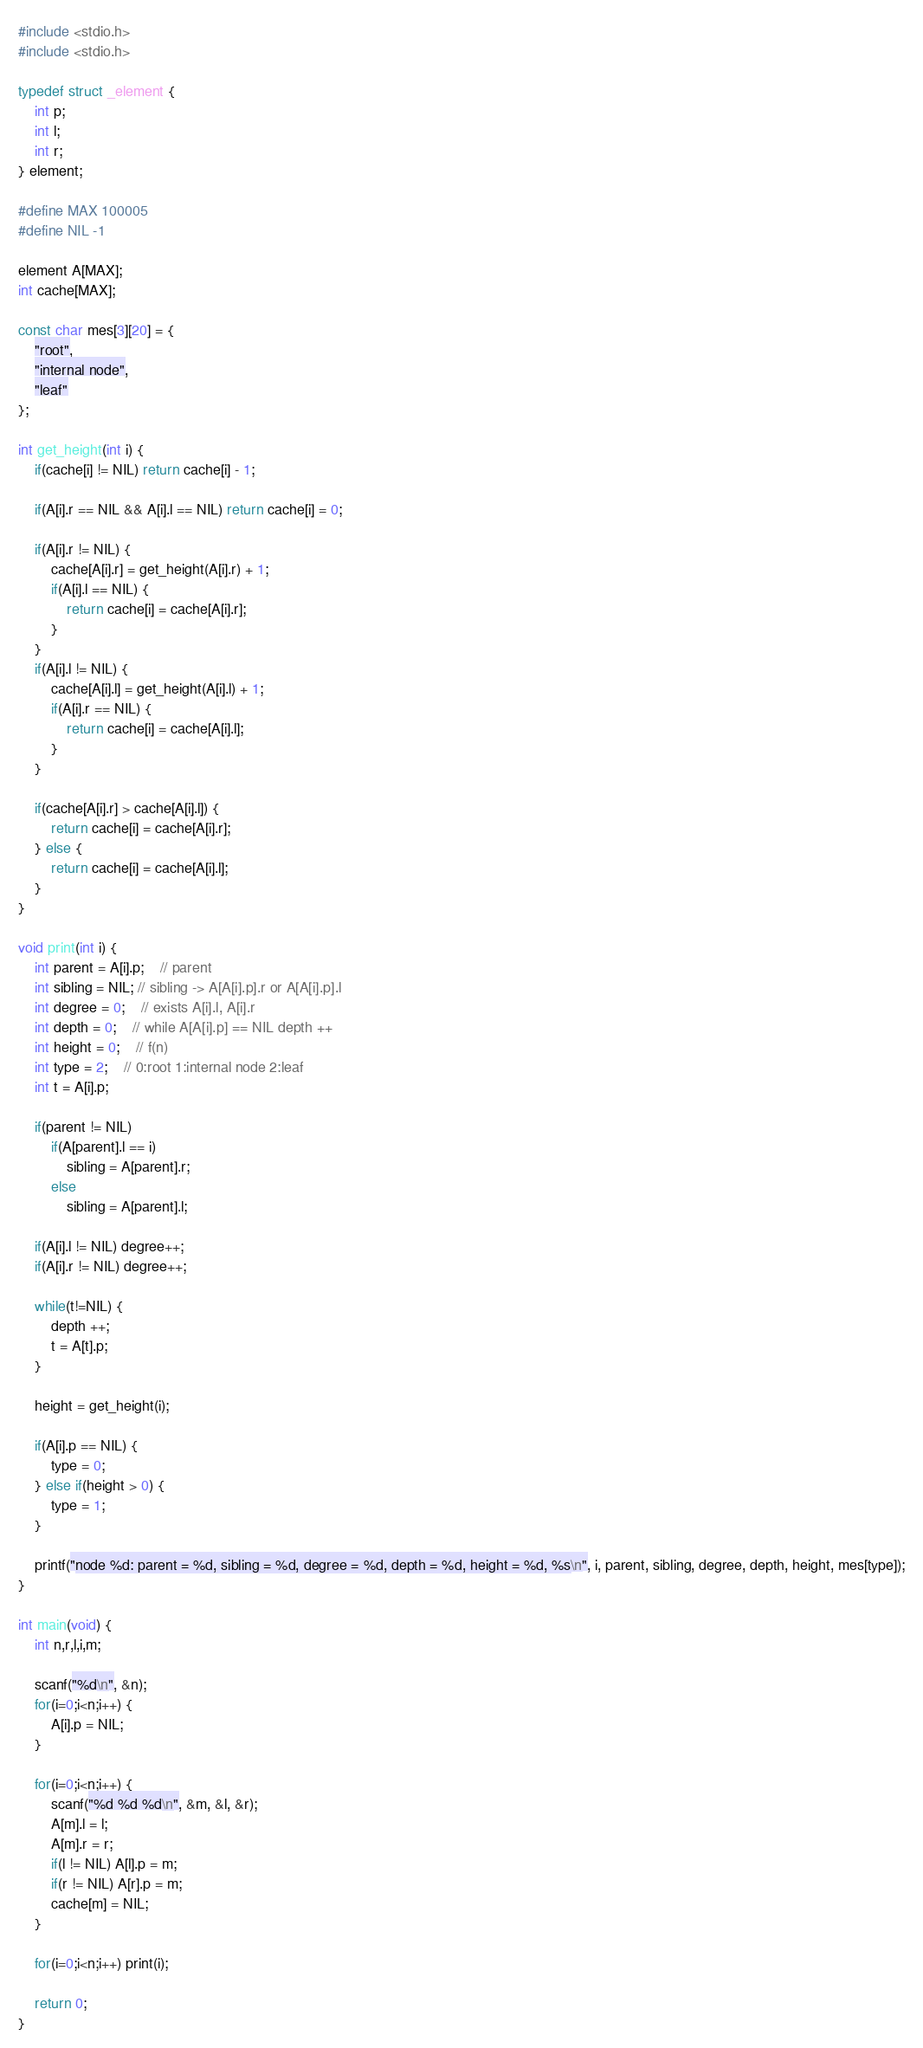Convert code to text. <code><loc_0><loc_0><loc_500><loc_500><_C_>#include <stdio.h>
#include <stdio.h>

typedef struct _element {
	int p;
	int l;
	int r;
} element;

#define MAX 100005
#define NIL -1

element A[MAX];
int cache[MAX];

const char mes[3][20] = {
	"root",
	"internal node",
	"leaf"
};

int get_height(int i) {
	if(cache[i] != NIL) return cache[i] - 1;

	if(A[i].r == NIL && A[i].l == NIL) return cache[i] = 0;
	
	if(A[i].r != NIL) {
		cache[A[i].r] = get_height(A[i].r) + 1;
		if(A[i].l == NIL) {
			return cache[i] = cache[A[i].r];
		}
	}
	if(A[i].l != NIL) {
		cache[A[i].l] = get_height(A[i].l) + 1;
		if(A[i].r == NIL) {
			return cache[i] = cache[A[i].l];
		}
	}
	
	if(cache[A[i].r] > cache[A[i].l]) {
		return cache[i] = cache[A[i].r];
	} else {
		return cache[i] = cache[A[i].l];
	}
}

void print(int i) {
	int parent = A[i].p;	// parent
	int sibling = NIL; // sibling -> A[A[i].p].r or A[A[i].p].l
	int degree = 0;	// exists A[i].l, A[i].r
	int depth = 0;	// while A[A[i].p] == NIL depth ++
	int height = 0;	// f(n)
	int type = 2;	// 0:root 1:internal node 2:leaf
	int t = A[i].p;
	
	if(parent != NIL)
		if(A[parent].l == i)
			sibling = A[parent].r;
		else
			sibling = A[parent].l;
	
	if(A[i].l != NIL) degree++;
	if(A[i].r != NIL) degree++;
	
	while(t!=NIL) {
		depth ++;
		t = A[t].p;
	}
	
	height = get_height(i);
	
	if(A[i].p == NIL) {
		type = 0;
	} else if(height > 0) {
		type = 1;
	}
	
	printf("node %d: parent = %d, sibling = %d, degree = %d, depth = %d, height = %d, %s\n", i, parent, sibling, degree, depth, height, mes[type]);
}

int main(void) {
	int n,r,l,i,m;
	
	scanf("%d\n", &n);
	for(i=0;i<n;i++) {
		A[i].p = NIL;
	}	
	
	for(i=0;i<n;i++) {
		scanf("%d %d %d\n", &m, &l, &r);
		A[m].l = l;
		A[m].r = r;
		if(l != NIL) A[l].p = m;
		if(r != NIL) A[r].p = m;
		cache[m] = NIL;
	}
	
	for(i=0;i<n;i++) print(i);
	
	return 0;
}</code> 